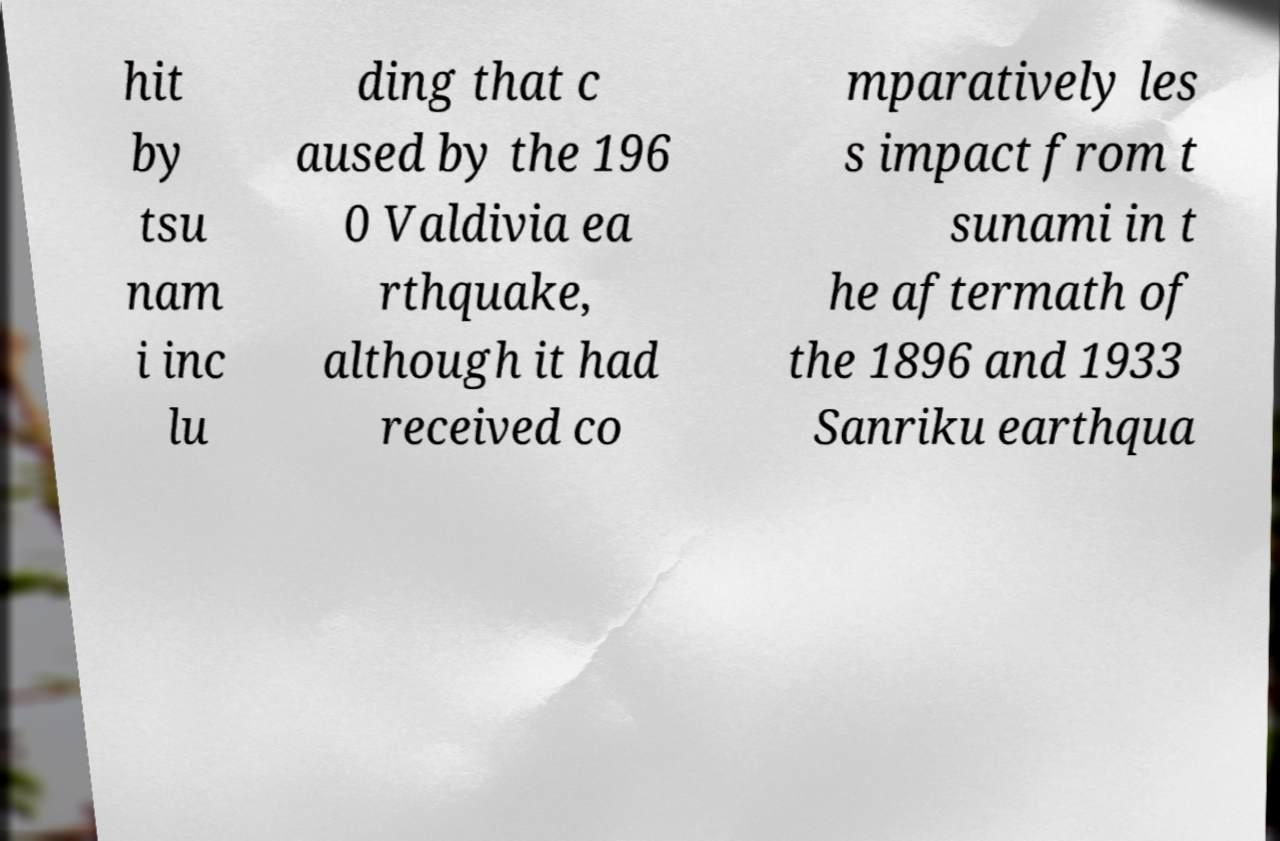Could you extract and type out the text from this image? hit by tsu nam i inc lu ding that c aused by the 196 0 Valdivia ea rthquake, although it had received co mparatively les s impact from t sunami in t he aftermath of the 1896 and 1933 Sanriku earthqua 